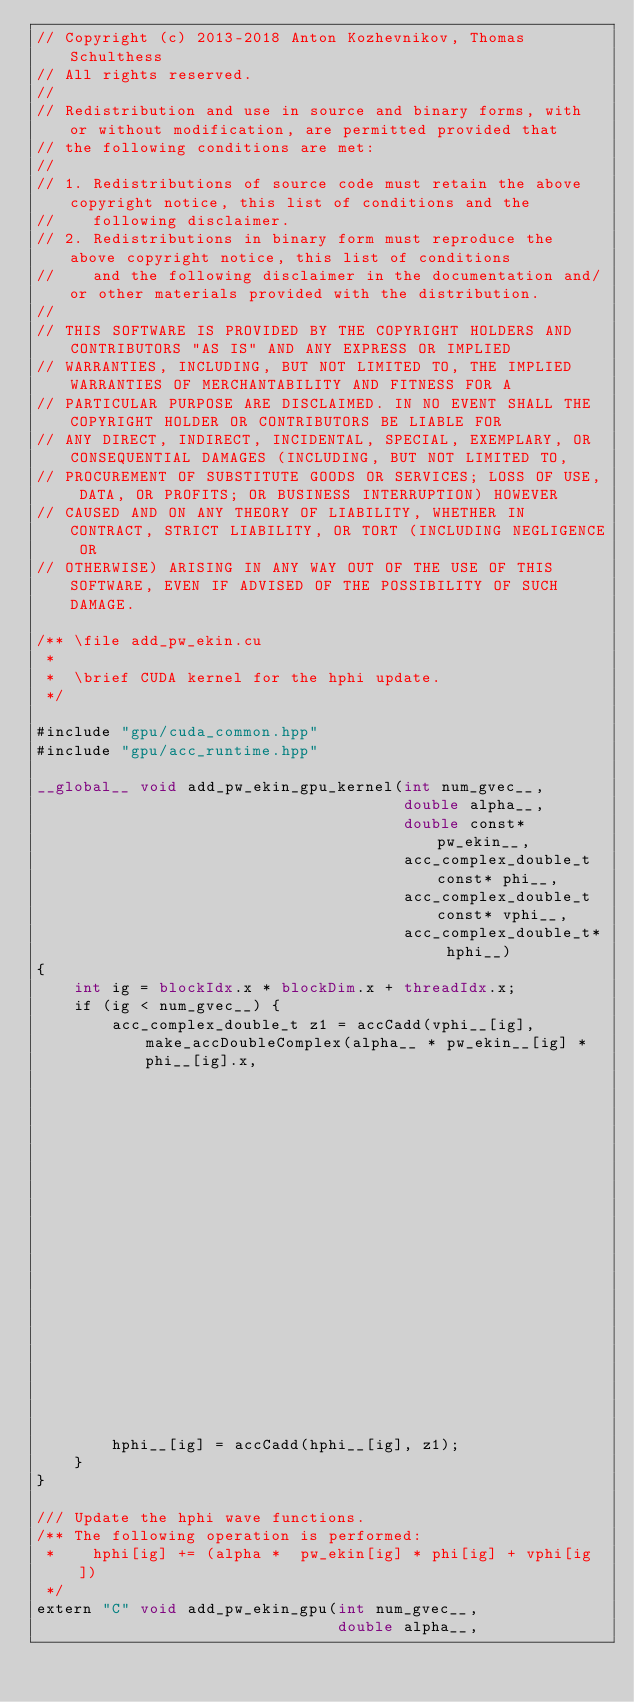Convert code to text. <code><loc_0><loc_0><loc_500><loc_500><_Cuda_>// Copyright (c) 2013-2018 Anton Kozhevnikov, Thomas Schulthess
// All rights reserved.
//
// Redistribution and use in source and binary forms, with or without modification, are permitted provided that
// the following conditions are met:
//
// 1. Redistributions of source code must retain the above copyright notice, this list of conditions and the
//    following disclaimer.
// 2. Redistributions in binary form must reproduce the above copyright notice, this list of conditions
//    and the following disclaimer in the documentation and/or other materials provided with the distribution.
//
// THIS SOFTWARE IS PROVIDED BY THE COPYRIGHT HOLDERS AND CONTRIBUTORS "AS IS" AND ANY EXPRESS OR IMPLIED
// WARRANTIES, INCLUDING, BUT NOT LIMITED TO, THE IMPLIED WARRANTIES OF MERCHANTABILITY AND FITNESS FOR A
// PARTICULAR PURPOSE ARE DISCLAIMED. IN NO EVENT SHALL THE COPYRIGHT HOLDER OR CONTRIBUTORS BE LIABLE FOR
// ANY DIRECT, INDIRECT, INCIDENTAL, SPECIAL, EXEMPLARY, OR CONSEQUENTIAL DAMAGES (INCLUDING, BUT NOT LIMITED TO,
// PROCUREMENT OF SUBSTITUTE GOODS OR SERVICES; LOSS OF USE, DATA, OR PROFITS; OR BUSINESS INTERRUPTION) HOWEVER
// CAUSED AND ON ANY THEORY OF LIABILITY, WHETHER IN CONTRACT, STRICT LIABILITY, OR TORT (INCLUDING NEGLIGENCE OR
// OTHERWISE) ARISING IN ANY WAY OUT OF THE USE OF THIS SOFTWARE, EVEN IF ADVISED OF THE POSSIBILITY OF SUCH DAMAGE.

/** \file add_pw_ekin.cu
 *
 *  \brief CUDA kernel for the hphi update.
 */

#include "gpu/cuda_common.hpp"
#include "gpu/acc_runtime.hpp"

__global__ void add_pw_ekin_gpu_kernel(int num_gvec__,
                                       double alpha__,
                                       double const* pw_ekin__,
                                       acc_complex_double_t const* phi__,
                                       acc_complex_double_t const* vphi__,
                                       acc_complex_double_t* hphi__)
{
    int ig = blockIdx.x * blockDim.x + threadIdx.x;
    if (ig < num_gvec__) {
        acc_complex_double_t z1 = accCadd(vphi__[ig], make_accDoubleComplex(alpha__ * pw_ekin__[ig] * phi__[ig].x, 
                                                                     alpha__ * pw_ekin__[ig] * phi__[ig].y));
        hphi__[ig] = accCadd(hphi__[ig], z1);
    }
}

/// Update the hphi wave functions.
/** The following operation is performed:
 *    hphi[ig] += (alpha *  pw_ekin[ig] * phi[ig] + vphi[ig])
 */
extern "C" void add_pw_ekin_gpu(int num_gvec__,
                                double alpha__,</code> 